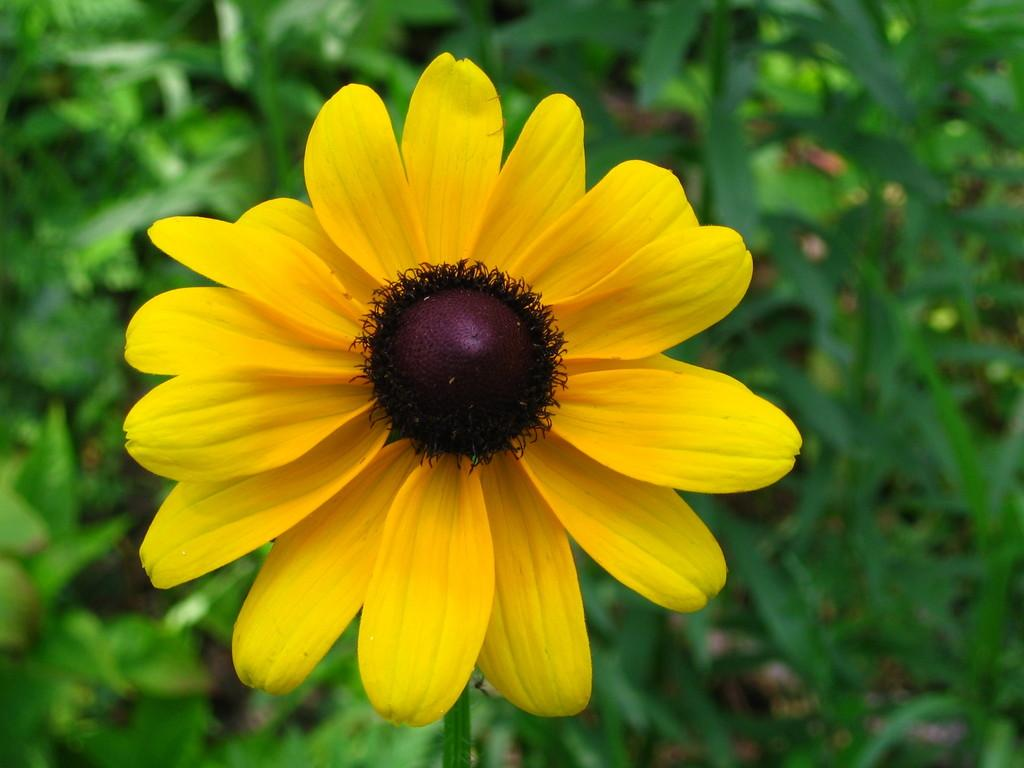What is the main subject of the image? There is a flower in the image. Can you describe the background of the image? There are leaves in the background of the image. What type of iron can be seen in the wilderness in the image? There is no iron or wilderness present in the image; it features a flower and leaves. 